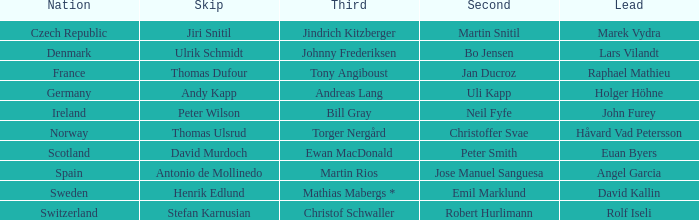Which Skip has a Third of tony angiboust? Thomas Dufour. 